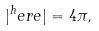<formula> <loc_0><loc_0><loc_500><loc_500>| ^ { h } e r e | = 4 \pi ,</formula> 